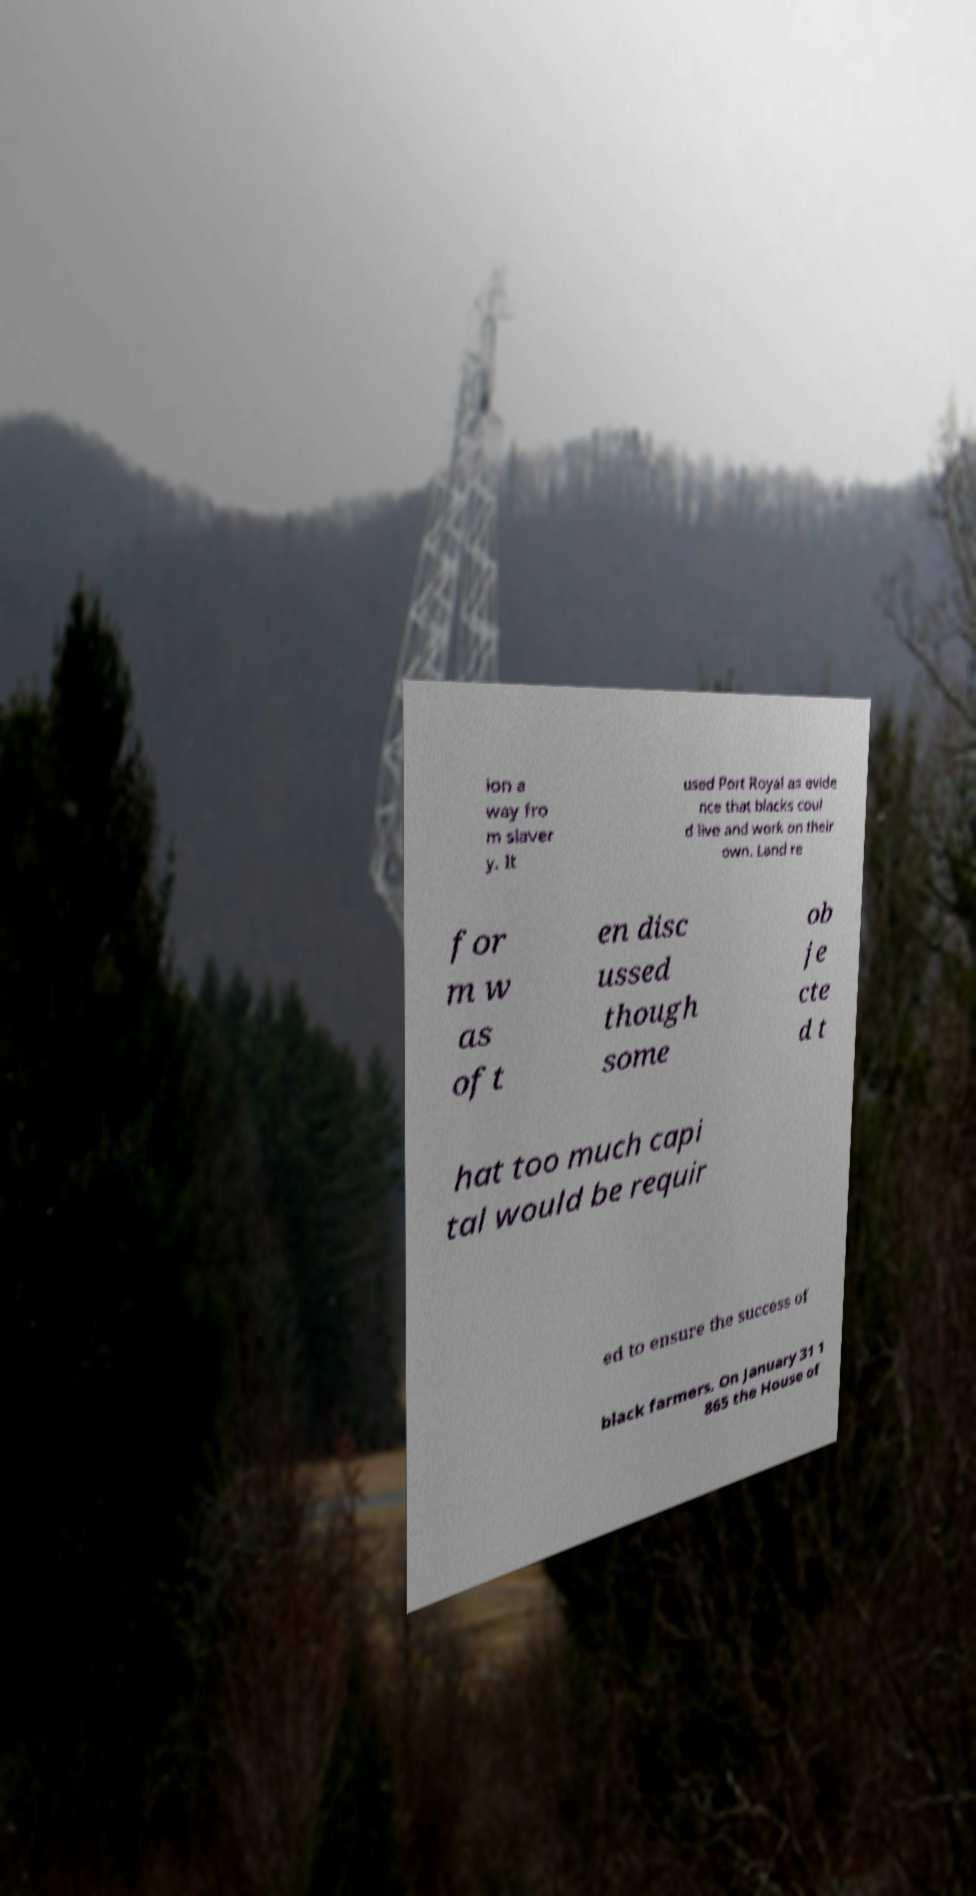For documentation purposes, I need the text within this image transcribed. Could you provide that? ion a way fro m slaver y. It used Port Royal as evide nce that blacks coul d live and work on their own. Land re for m w as oft en disc ussed though some ob je cte d t hat too much capi tal would be requir ed to ensure the success of black farmers. On January 31 1 865 the House of 